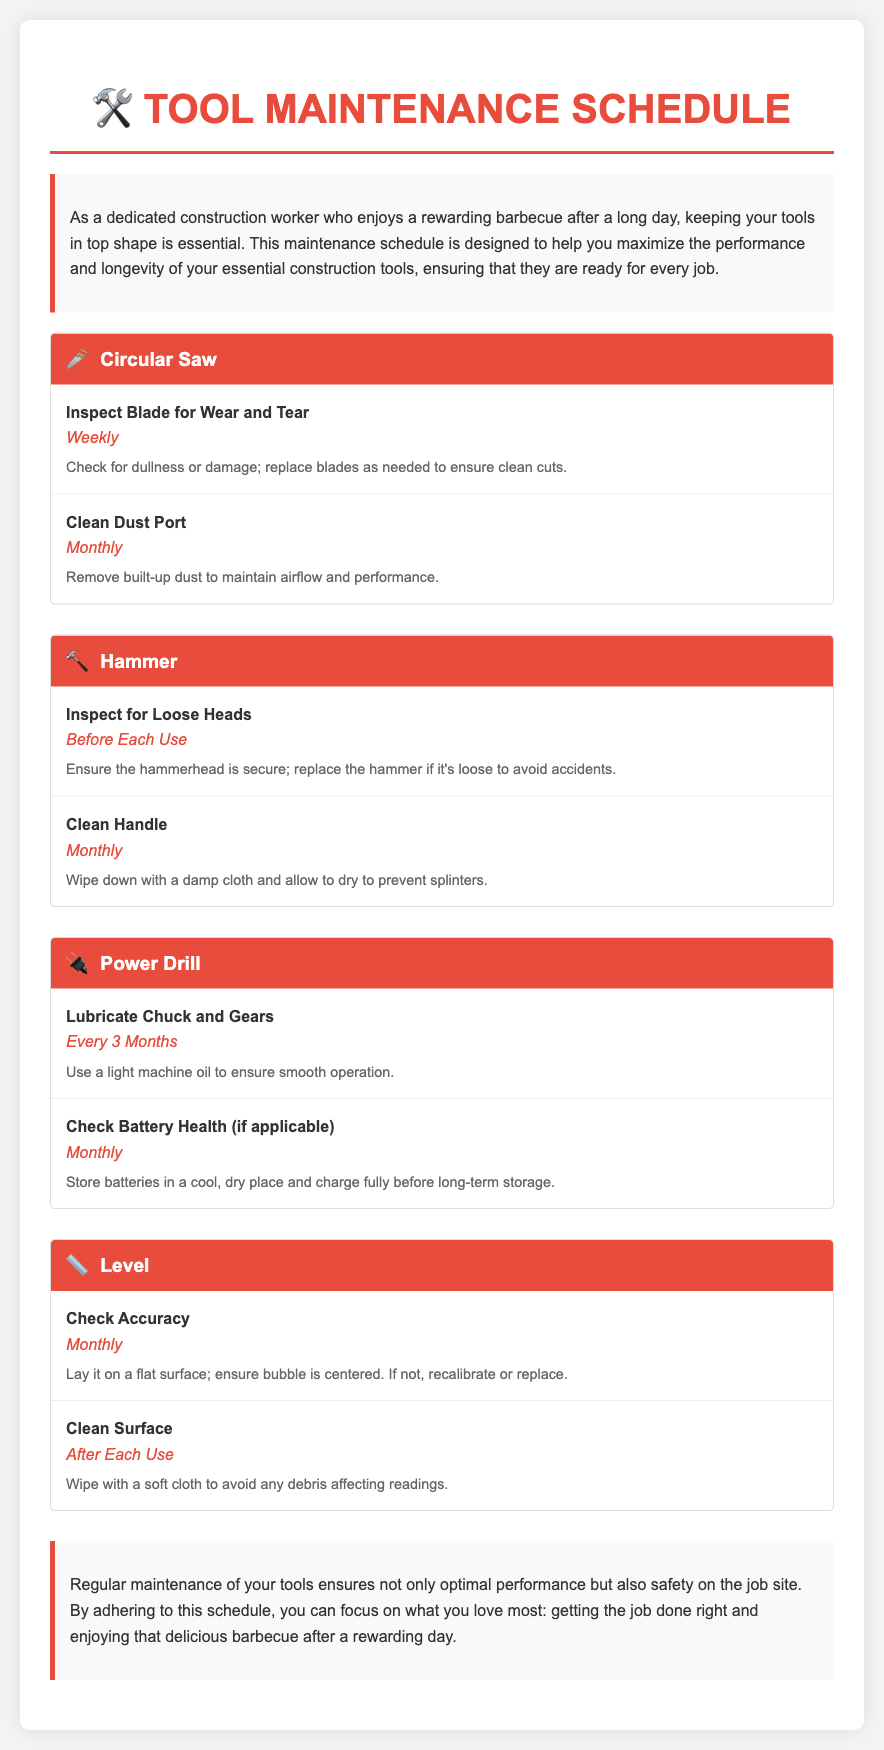What is the recommended frequency for inspecting the circular saw blade? The frequency for inspecting the circular saw blade is stated as weekly in the document.
Answer: Weekly How often should the hammer handle be cleaned? The document specifies that the hammer handle should be cleaned monthly.
Answer: Monthly What maintenance task is required before each use of the hammer? The task required before each use of the hammer is to inspect for loose heads.
Answer: Inspect for Loose Heads What should be done every 3 months for the power drill? According to the document, the chuck and gears of the power drill should be lubricated every 3 months.
Answer: Lubricate Chuck and Gears What is the purpose of cleaning the level's surface after each use? The document explains that cleaning the level's surface helps avoid any debris affecting readings.
Answer: Avoid debris affecting readings How frequently should the dust port of the circular saw be cleaned? The document states that the dust port should be cleaned monthly.
Answer: Monthly What tool requires checking battery health? The tool that requires checking the battery health is the power drill.
Answer: Power Drill Why is it important to inspect the hammerhead? The document highlights that ensuring the hammerhead is secure avoids accidents, making it an important maintenance task.
Answer: Avoid accidents What is the intended audience for this tool maintenance schedule? The document targets dedicated construction workers who rely on the optimal performance of their tools.
Answer: Construction workers 